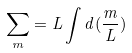Convert formula to latex. <formula><loc_0><loc_0><loc_500><loc_500>\sum _ { m } = L \int d ( \frac { m } { L } )</formula> 